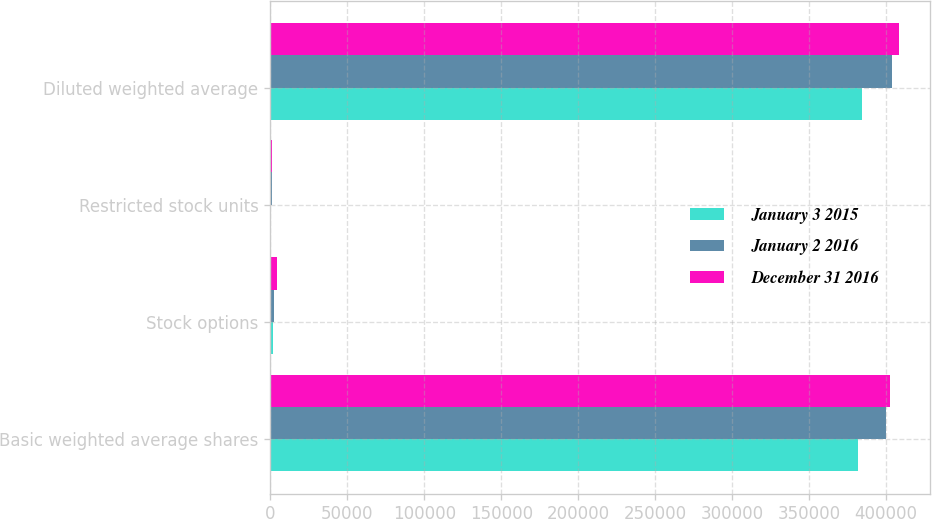Convert chart. <chart><loc_0><loc_0><loc_500><loc_500><stacked_bar_chart><ecel><fcel>Basic weighted average shares<fcel>Stock options<fcel>Restricted stock units<fcel>Diluted weighted average<nl><fcel>January 3 2015<fcel>381782<fcel>1983<fcel>756<fcel>384566<nl><fcel>January 2 2016<fcel>399891<fcel>2719<fcel>1009<fcel>403659<nl><fcel>December 31 2016<fcel>402300<fcel>4452<fcel>1292<fcel>408044<nl></chart> 